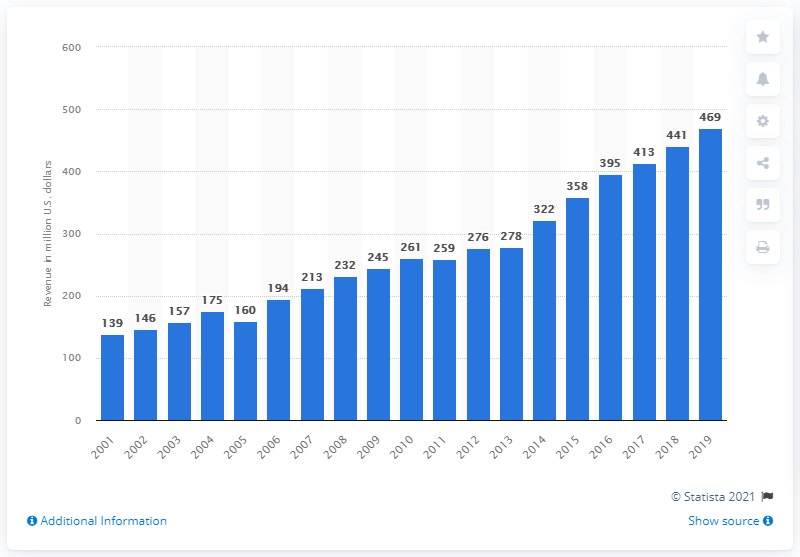Point out several critical features in this image. The revenue of the New Orleans Saints in 2019 was 469 million dollars. 